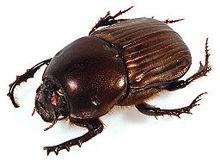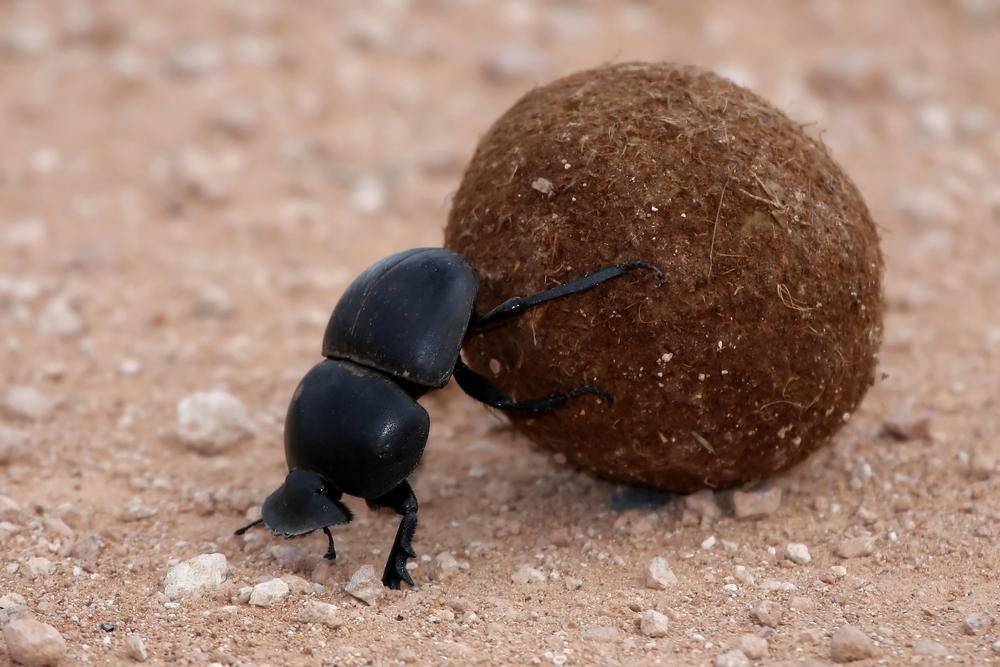The first image is the image on the left, the second image is the image on the right. For the images shown, is this caption "There is no ball in the image on the left" true? Answer yes or no. Yes. The first image is the image on the left, the second image is the image on the right. Examine the images to the left and right. Is the description "There is a bug in each image on a ball of sediment." accurate? Answer yes or no. No. The first image is the image on the left, the second image is the image on the right. Evaluate the accuracy of this statement regarding the images: "There are exactly two insects in one of the images.". Is it true? Answer yes or no. No. 